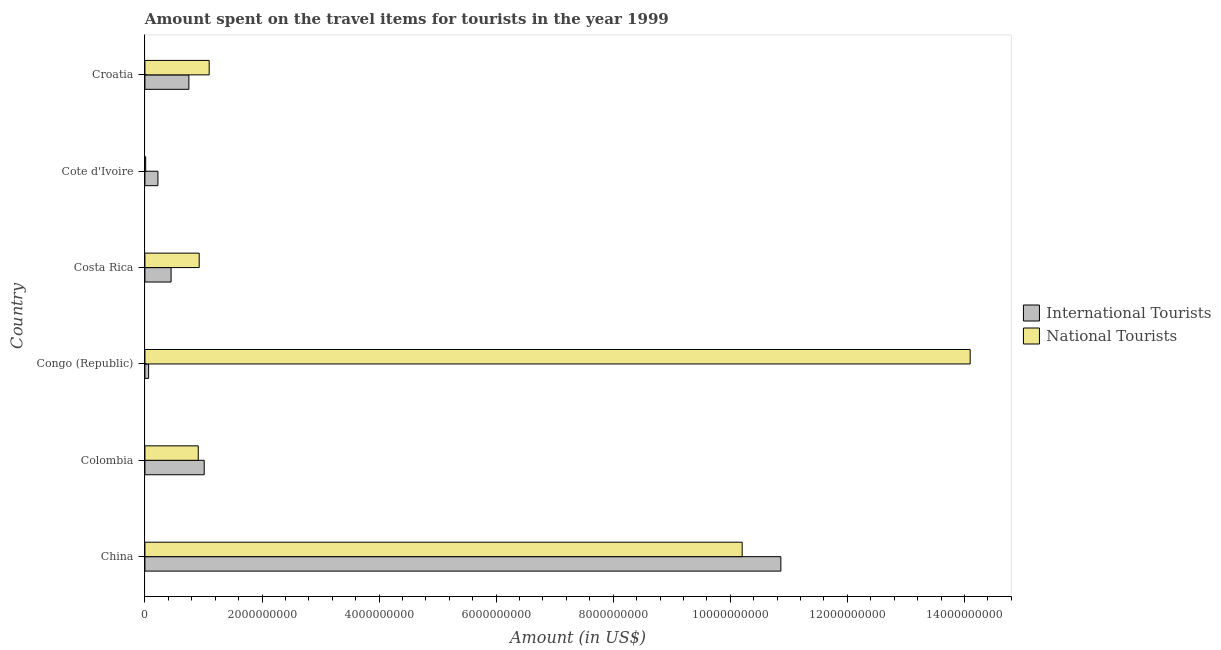Are the number of bars per tick equal to the number of legend labels?
Your answer should be compact. Yes. Are the number of bars on each tick of the Y-axis equal?
Make the answer very short. Yes. What is the label of the 2nd group of bars from the top?
Offer a very short reply. Cote d'Ivoire. In how many cases, is the number of bars for a given country not equal to the number of legend labels?
Your response must be concise. 0. What is the amount spent on travel items of national tourists in China?
Provide a short and direct response. 1.02e+1. Across all countries, what is the maximum amount spent on travel items of international tourists?
Make the answer very short. 1.09e+1. Across all countries, what is the minimum amount spent on travel items of national tourists?
Make the answer very short. 1.30e+07. In which country was the amount spent on travel items of national tourists maximum?
Your answer should be very brief. Congo (Republic). In which country was the amount spent on travel items of national tourists minimum?
Offer a very short reply. Cote d'Ivoire. What is the total amount spent on travel items of international tourists in the graph?
Keep it short and to the point. 1.34e+1. What is the difference between the amount spent on travel items of international tourists in China and that in Cote d'Ivoire?
Ensure brevity in your answer.  1.06e+1. What is the difference between the amount spent on travel items of national tourists in Costa Rica and the amount spent on travel items of international tourists in Congo (Republic)?
Ensure brevity in your answer.  8.64e+08. What is the average amount spent on travel items of national tourists per country?
Offer a terse response. 4.54e+09. What is the difference between the amount spent on travel items of international tourists and amount spent on travel items of national tourists in Congo (Republic)?
Your answer should be very brief. -1.40e+1. What is the ratio of the amount spent on travel items of international tourists in Costa Rica to that in Croatia?
Your answer should be very brief. 0.59. What is the difference between the highest and the second highest amount spent on travel items of international tourists?
Keep it short and to the point. 9.85e+09. What is the difference between the highest and the lowest amount spent on travel items of national tourists?
Provide a succinct answer. 1.41e+1. In how many countries, is the amount spent on travel items of national tourists greater than the average amount spent on travel items of national tourists taken over all countries?
Your response must be concise. 2. Is the sum of the amount spent on travel items of international tourists in China and Cote d'Ivoire greater than the maximum amount spent on travel items of national tourists across all countries?
Your response must be concise. No. What does the 2nd bar from the top in China represents?
Ensure brevity in your answer.  International Tourists. What does the 1st bar from the bottom in Congo (Republic) represents?
Your answer should be very brief. International Tourists. How many bars are there?
Provide a succinct answer. 12. How many countries are there in the graph?
Your response must be concise. 6. What is the difference between two consecutive major ticks on the X-axis?
Offer a terse response. 2.00e+09. Does the graph contain any zero values?
Offer a terse response. No. Where does the legend appear in the graph?
Your response must be concise. Center right. How many legend labels are there?
Offer a very short reply. 2. How are the legend labels stacked?
Provide a succinct answer. Vertical. What is the title of the graph?
Provide a succinct answer. Amount spent on the travel items for tourists in the year 1999. Does "Automatic Teller Machines" appear as one of the legend labels in the graph?
Make the answer very short. No. What is the label or title of the X-axis?
Make the answer very short. Amount (in US$). What is the Amount (in US$) of International Tourists in China?
Provide a short and direct response. 1.09e+1. What is the Amount (in US$) of National Tourists in China?
Your response must be concise. 1.02e+1. What is the Amount (in US$) in International Tourists in Colombia?
Offer a very short reply. 1.01e+09. What is the Amount (in US$) of National Tourists in Colombia?
Your answer should be compact. 9.11e+08. What is the Amount (in US$) of International Tourists in Congo (Republic)?
Offer a very short reply. 6.30e+07. What is the Amount (in US$) in National Tourists in Congo (Republic)?
Ensure brevity in your answer.  1.41e+1. What is the Amount (in US$) in International Tourists in Costa Rica?
Offer a terse response. 4.47e+08. What is the Amount (in US$) of National Tourists in Costa Rica?
Your answer should be compact. 9.27e+08. What is the Amount (in US$) in International Tourists in Cote d'Ivoire?
Provide a short and direct response. 2.22e+08. What is the Amount (in US$) of National Tourists in Cote d'Ivoire?
Make the answer very short. 1.30e+07. What is the Amount (in US$) in International Tourists in Croatia?
Your answer should be compact. 7.51e+08. What is the Amount (in US$) in National Tourists in Croatia?
Your answer should be compact. 1.10e+09. Across all countries, what is the maximum Amount (in US$) of International Tourists?
Your answer should be very brief. 1.09e+1. Across all countries, what is the maximum Amount (in US$) of National Tourists?
Ensure brevity in your answer.  1.41e+1. Across all countries, what is the minimum Amount (in US$) of International Tourists?
Offer a terse response. 6.30e+07. Across all countries, what is the minimum Amount (in US$) in National Tourists?
Offer a very short reply. 1.30e+07. What is the total Amount (in US$) in International Tourists in the graph?
Your response must be concise. 1.34e+1. What is the total Amount (in US$) of National Tourists in the graph?
Ensure brevity in your answer.  2.72e+1. What is the difference between the Amount (in US$) in International Tourists in China and that in Colombia?
Provide a short and direct response. 9.85e+09. What is the difference between the Amount (in US$) of National Tourists in China and that in Colombia?
Offer a terse response. 9.29e+09. What is the difference between the Amount (in US$) of International Tourists in China and that in Congo (Republic)?
Your answer should be very brief. 1.08e+1. What is the difference between the Amount (in US$) of National Tourists in China and that in Congo (Republic)?
Your response must be concise. -3.90e+09. What is the difference between the Amount (in US$) in International Tourists in China and that in Costa Rica?
Your answer should be compact. 1.04e+1. What is the difference between the Amount (in US$) of National Tourists in China and that in Costa Rica?
Offer a very short reply. 9.28e+09. What is the difference between the Amount (in US$) of International Tourists in China and that in Cote d'Ivoire?
Make the answer very short. 1.06e+1. What is the difference between the Amount (in US$) in National Tourists in China and that in Cote d'Ivoire?
Ensure brevity in your answer.  1.02e+1. What is the difference between the Amount (in US$) of International Tourists in China and that in Croatia?
Keep it short and to the point. 1.01e+1. What is the difference between the Amount (in US$) in National Tourists in China and that in Croatia?
Keep it short and to the point. 9.10e+09. What is the difference between the Amount (in US$) in International Tourists in Colombia and that in Congo (Republic)?
Ensure brevity in your answer.  9.50e+08. What is the difference between the Amount (in US$) in National Tourists in Colombia and that in Congo (Republic)?
Your answer should be compact. -1.32e+1. What is the difference between the Amount (in US$) in International Tourists in Colombia and that in Costa Rica?
Provide a short and direct response. 5.66e+08. What is the difference between the Amount (in US$) in National Tourists in Colombia and that in Costa Rica?
Provide a short and direct response. -1.60e+07. What is the difference between the Amount (in US$) in International Tourists in Colombia and that in Cote d'Ivoire?
Ensure brevity in your answer.  7.91e+08. What is the difference between the Amount (in US$) of National Tourists in Colombia and that in Cote d'Ivoire?
Keep it short and to the point. 8.98e+08. What is the difference between the Amount (in US$) of International Tourists in Colombia and that in Croatia?
Provide a short and direct response. 2.62e+08. What is the difference between the Amount (in US$) in National Tourists in Colombia and that in Croatia?
Your answer should be compact. -1.87e+08. What is the difference between the Amount (in US$) of International Tourists in Congo (Republic) and that in Costa Rica?
Offer a terse response. -3.84e+08. What is the difference between the Amount (in US$) of National Tourists in Congo (Republic) and that in Costa Rica?
Keep it short and to the point. 1.32e+1. What is the difference between the Amount (in US$) of International Tourists in Congo (Republic) and that in Cote d'Ivoire?
Ensure brevity in your answer.  -1.59e+08. What is the difference between the Amount (in US$) of National Tourists in Congo (Republic) and that in Cote d'Ivoire?
Your answer should be compact. 1.41e+1. What is the difference between the Amount (in US$) of International Tourists in Congo (Republic) and that in Croatia?
Offer a very short reply. -6.88e+08. What is the difference between the Amount (in US$) in National Tourists in Congo (Republic) and that in Croatia?
Make the answer very short. 1.30e+1. What is the difference between the Amount (in US$) in International Tourists in Costa Rica and that in Cote d'Ivoire?
Your answer should be very brief. 2.25e+08. What is the difference between the Amount (in US$) in National Tourists in Costa Rica and that in Cote d'Ivoire?
Provide a succinct answer. 9.14e+08. What is the difference between the Amount (in US$) of International Tourists in Costa Rica and that in Croatia?
Your response must be concise. -3.04e+08. What is the difference between the Amount (in US$) of National Tourists in Costa Rica and that in Croatia?
Provide a succinct answer. -1.71e+08. What is the difference between the Amount (in US$) of International Tourists in Cote d'Ivoire and that in Croatia?
Ensure brevity in your answer.  -5.29e+08. What is the difference between the Amount (in US$) in National Tourists in Cote d'Ivoire and that in Croatia?
Give a very brief answer. -1.08e+09. What is the difference between the Amount (in US$) in International Tourists in China and the Amount (in US$) in National Tourists in Colombia?
Your response must be concise. 9.95e+09. What is the difference between the Amount (in US$) of International Tourists in China and the Amount (in US$) of National Tourists in Congo (Republic)?
Ensure brevity in your answer.  -3.23e+09. What is the difference between the Amount (in US$) in International Tourists in China and the Amount (in US$) in National Tourists in Costa Rica?
Your answer should be very brief. 9.94e+09. What is the difference between the Amount (in US$) in International Tourists in China and the Amount (in US$) in National Tourists in Cote d'Ivoire?
Keep it short and to the point. 1.09e+1. What is the difference between the Amount (in US$) of International Tourists in China and the Amount (in US$) of National Tourists in Croatia?
Make the answer very short. 9.77e+09. What is the difference between the Amount (in US$) in International Tourists in Colombia and the Amount (in US$) in National Tourists in Congo (Republic)?
Offer a very short reply. -1.31e+1. What is the difference between the Amount (in US$) in International Tourists in Colombia and the Amount (in US$) in National Tourists in Costa Rica?
Ensure brevity in your answer.  8.60e+07. What is the difference between the Amount (in US$) in International Tourists in Colombia and the Amount (in US$) in National Tourists in Croatia?
Provide a short and direct response. -8.50e+07. What is the difference between the Amount (in US$) in International Tourists in Congo (Republic) and the Amount (in US$) in National Tourists in Costa Rica?
Offer a very short reply. -8.64e+08. What is the difference between the Amount (in US$) of International Tourists in Congo (Republic) and the Amount (in US$) of National Tourists in Cote d'Ivoire?
Offer a very short reply. 5.00e+07. What is the difference between the Amount (in US$) in International Tourists in Congo (Republic) and the Amount (in US$) in National Tourists in Croatia?
Offer a terse response. -1.04e+09. What is the difference between the Amount (in US$) in International Tourists in Costa Rica and the Amount (in US$) in National Tourists in Cote d'Ivoire?
Give a very brief answer. 4.34e+08. What is the difference between the Amount (in US$) in International Tourists in Costa Rica and the Amount (in US$) in National Tourists in Croatia?
Keep it short and to the point. -6.51e+08. What is the difference between the Amount (in US$) in International Tourists in Cote d'Ivoire and the Amount (in US$) in National Tourists in Croatia?
Provide a short and direct response. -8.76e+08. What is the average Amount (in US$) in International Tourists per country?
Your answer should be compact. 2.23e+09. What is the average Amount (in US$) in National Tourists per country?
Provide a succinct answer. 4.54e+09. What is the difference between the Amount (in US$) in International Tourists and Amount (in US$) in National Tourists in China?
Your answer should be compact. 6.61e+08. What is the difference between the Amount (in US$) of International Tourists and Amount (in US$) of National Tourists in Colombia?
Ensure brevity in your answer.  1.02e+08. What is the difference between the Amount (in US$) in International Tourists and Amount (in US$) in National Tourists in Congo (Republic)?
Your answer should be very brief. -1.40e+1. What is the difference between the Amount (in US$) in International Tourists and Amount (in US$) in National Tourists in Costa Rica?
Your answer should be very brief. -4.80e+08. What is the difference between the Amount (in US$) in International Tourists and Amount (in US$) in National Tourists in Cote d'Ivoire?
Your answer should be very brief. 2.09e+08. What is the difference between the Amount (in US$) of International Tourists and Amount (in US$) of National Tourists in Croatia?
Provide a short and direct response. -3.47e+08. What is the ratio of the Amount (in US$) in International Tourists in China to that in Colombia?
Offer a terse response. 10.72. What is the ratio of the Amount (in US$) in National Tourists in China to that in Colombia?
Provide a short and direct response. 11.2. What is the ratio of the Amount (in US$) in International Tourists in China to that in Congo (Republic)?
Your response must be concise. 172.44. What is the ratio of the Amount (in US$) in National Tourists in China to that in Congo (Republic)?
Your answer should be very brief. 0.72. What is the ratio of the Amount (in US$) in International Tourists in China to that in Costa Rica?
Give a very brief answer. 24.3. What is the ratio of the Amount (in US$) in National Tourists in China to that in Costa Rica?
Ensure brevity in your answer.  11.01. What is the ratio of the Amount (in US$) in International Tourists in China to that in Cote d'Ivoire?
Give a very brief answer. 48.94. What is the ratio of the Amount (in US$) of National Tourists in China to that in Cote d'Ivoire?
Keep it short and to the point. 784.85. What is the ratio of the Amount (in US$) of International Tourists in China to that in Croatia?
Keep it short and to the point. 14.47. What is the ratio of the Amount (in US$) of National Tourists in China to that in Croatia?
Your answer should be very brief. 9.29. What is the ratio of the Amount (in US$) in International Tourists in Colombia to that in Congo (Republic)?
Provide a succinct answer. 16.08. What is the ratio of the Amount (in US$) in National Tourists in Colombia to that in Congo (Republic)?
Make the answer very short. 0.06. What is the ratio of the Amount (in US$) in International Tourists in Colombia to that in Costa Rica?
Keep it short and to the point. 2.27. What is the ratio of the Amount (in US$) in National Tourists in Colombia to that in Costa Rica?
Keep it short and to the point. 0.98. What is the ratio of the Amount (in US$) in International Tourists in Colombia to that in Cote d'Ivoire?
Keep it short and to the point. 4.56. What is the ratio of the Amount (in US$) in National Tourists in Colombia to that in Cote d'Ivoire?
Offer a terse response. 70.08. What is the ratio of the Amount (in US$) in International Tourists in Colombia to that in Croatia?
Offer a very short reply. 1.35. What is the ratio of the Amount (in US$) in National Tourists in Colombia to that in Croatia?
Offer a very short reply. 0.83. What is the ratio of the Amount (in US$) in International Tourists in Congo (Republic) to that in Costa Rica?
Keep it short and to the point. 0.14. What is the ratio of the Amount (in US$) of National Tourists in Congo (Republic) to that in Costa Rica?
Provide a succinct answer. 15.21. What is the ratio of the Amount (in US$) of International Tourists in Congo (Republic) to that in Cote d'Ivoire?
Offer a terse response. 0.28. What is the ratio of the Amount (in US$) in National Tourists in Congo (Republic) to that in Cote d'Ivoire?
Provide a succinct answer. 1084.46. What is the ratio of the Amount (in US$) in International Tourists in Congo (Republic) to that in Croatia?
Offer a terse response. 0.08. What is the ratio of the Amount (in US$) of National Tourists in Congo (Republic) to that in Croatia?
Your answer should be very brief. 12.84. What is the ratio of the Amount (in US$) of International Tourists in Costa Rica to that in Cote d'Ivoire?
Keep it short and to the point. 2.01. What is the ratio of the Amount (in US$) in National Tourists in Costa Rica to that in Cote d'Ivoire?
Your answer should be very brief. 71.31. What is the ratio of the Amount (in US$) in International Tourists in Costa Rica to that in Croatia?
Offer a very short reply. 0.6. What is the ratio of the Amount (in US$) in National Tourists in Costa Rica to that in Croatia?
Keep it short and to the point. 0.84. What is the ratio of the Amount (in US$) in International Tourists in Cote d'Ivoire to that in Croatia?
Keep it short and to the point. 0.3. What is the ratio of the Amount (in US$) in National Tourists in Cote d'Ivoire to that in Croatia?
Give a very brief answer. 0.01. What is the difference between the highest and the second highest Amount (in US$) of International Tourists?
Offer a terse response. 9.85e+09. What is the difference between the highest and the second highest Amount (in US$) in National Tourists?
Ensure brevity in your answer.  3.90e+09. What is the difference between the highest and the lowest Amount (in US$) in International Tourists?
Offer a terse response. 1.08e+1. What is the difference between the highest and the lowest Amount (in US$) of National Tourists?
Your response must be concise. 1.41e+1. 